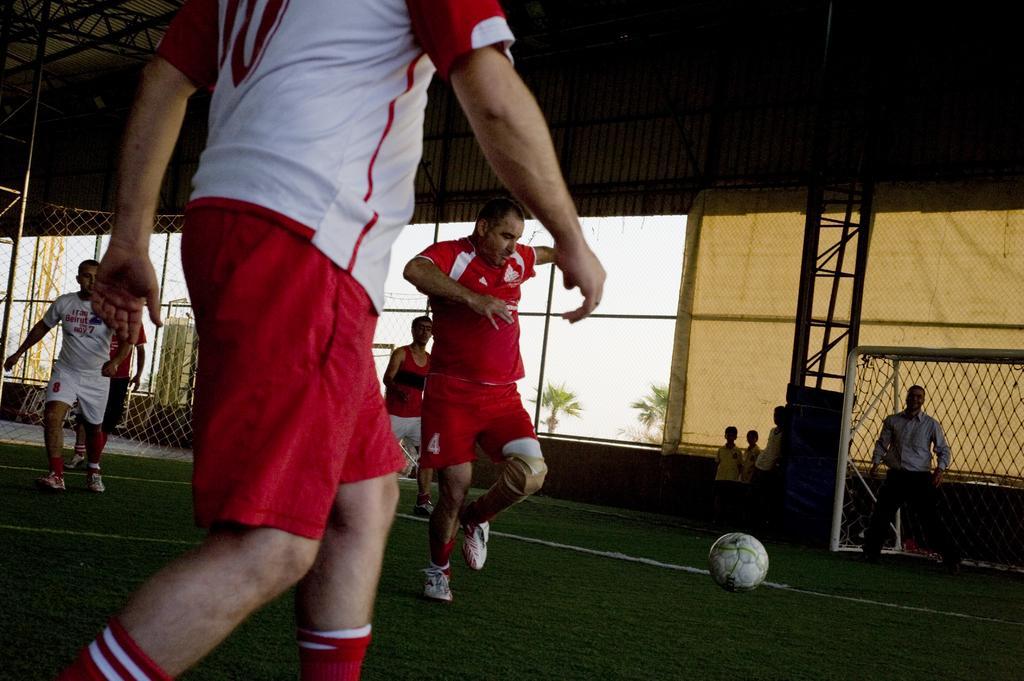Describe this image in one or two sentences. In this image I can see few persons playing football. I can see the ball. I can see football net. In the background I can see two trees. I can see the fencing. 